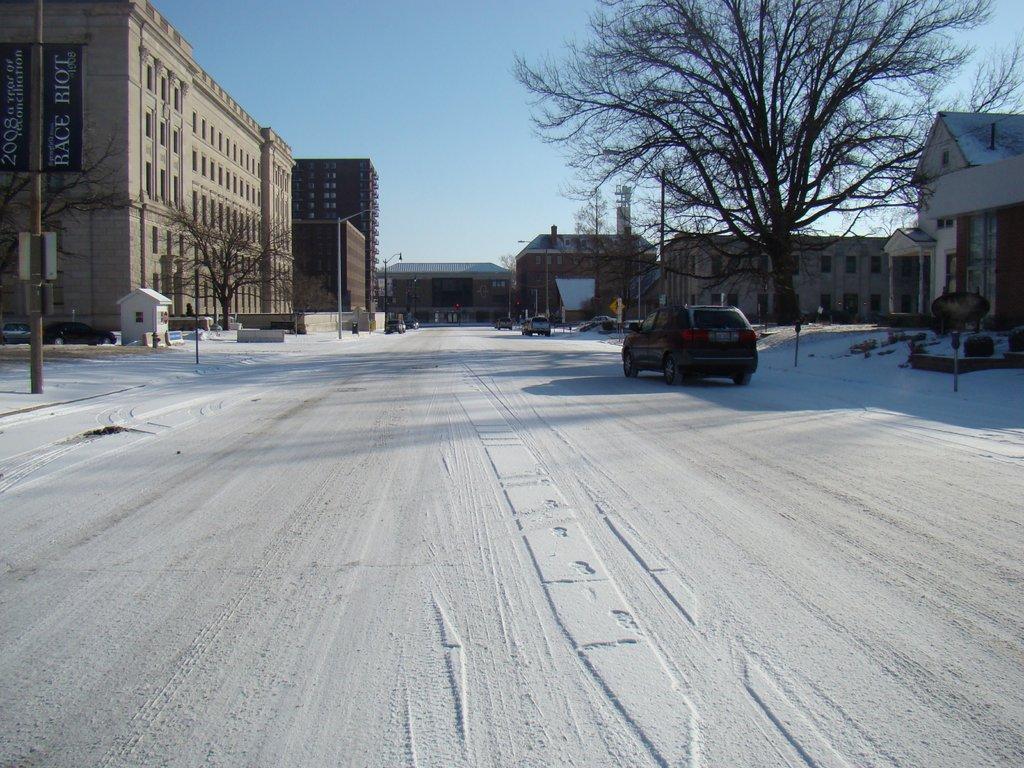Describe this image in one or two sentences. In the picture I can see the road covered with snow, I can see vehicles moving on the road, I can see dry trees, buildings on either side of the image, I can see poles and the sky in the background. 